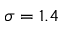<formula> <loc_0><loc_0><loc_500><loc_500>\sigma = 1 . 4</formula> 